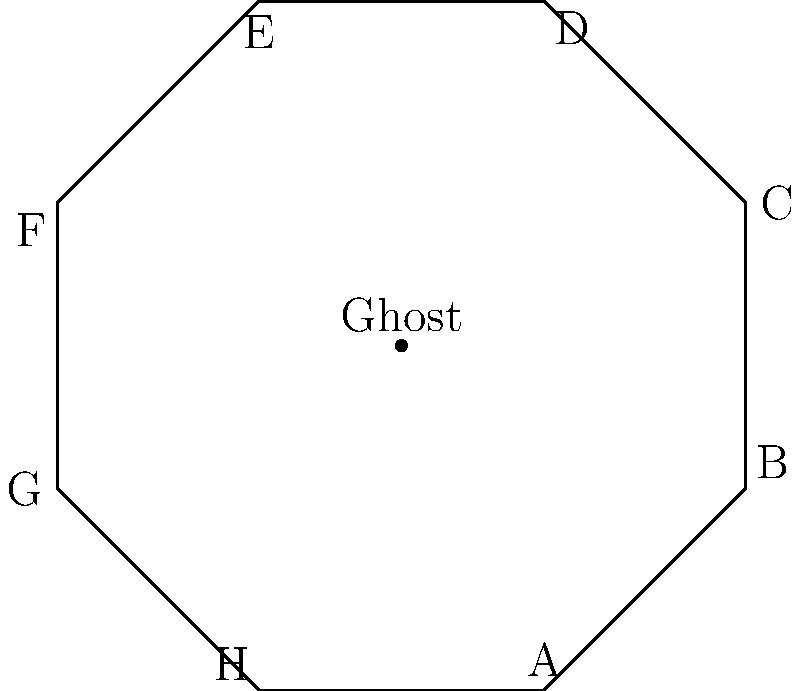In a haunted octagonal house, a mischievous ghost performs a series of rotations and reflections. If the ghost starts at the center and moves to corner A, then applies the operation $r^3s$ (where $r$ is a 45° clockwise rotation and $s$ is a reflection across the line from A to E), which corner will the ghost end up in? Let's break this down step-by-step:

1) The dihedral group $D_8$ describes the symmetries of an octagon. In this case, our haunted house floor plan is an octagon.

2) We start with the ghost at corner A.

3) The operation $r^3s$ means we first apply $s$ (reflection) and then $r^3$ (three 45° clockwise rotations).

4) Reflection $s$ across the line AE:
   A → A
   B → H
   C → G
   D → F
   E → E
   F → D
   G → C
   H → B

   So after reflection, the ghost is still at A.

5) Now we apply $r^3$, which is equivalent to rotating 135° clockwise:
   A → D
   B → E
   C → F
   D → G
   E → H
   F → A
   G → B
   H → C

6) Since the ghost was at A after the reflection, it will end up at D after the rotation.

Therefore, the ghost will end up at corner D.
Answer: D 